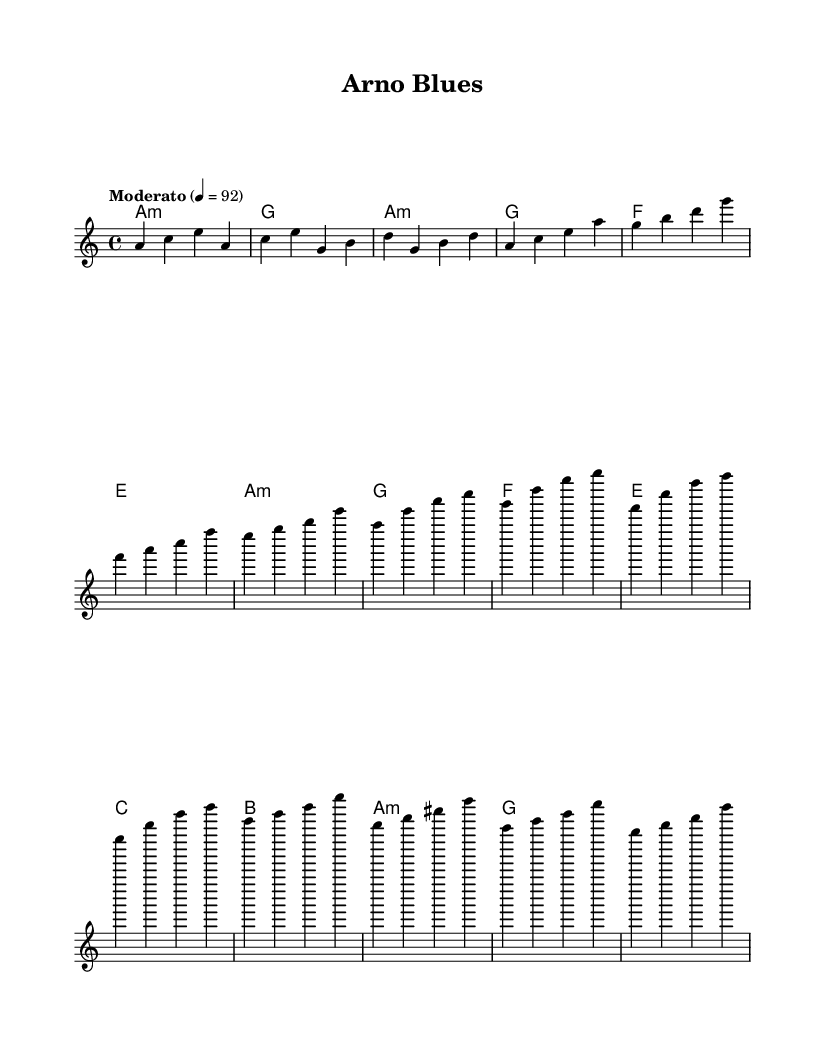What is the key signature of this music? The key signature shown in the piece is A minor, which typically has no sharps or flats. A minor is the relative minor of C major, and this is indicated at the beginning of the score.
Answer: A minor What is the time signature of this music? The time signature is 4/4, which indicates that there are four beats in a measure and a quarter note gets one beat. This can be observed from the time signature marking at the beginning of the score.
Answer: 4/4 What is the tempo marking of this music? The tempo marking is "Moderato," indicating a moderate speed of play. The number following that, 4 = 92, specifies the beats per minute, giving performers guidance on how fast to play the piece.
Answer: Moderato Which chord appears most frequently in the piece? The chord A minor appears frequently throughout the composition, particularly in the verses and chorus sections. This can be seen from the chord symbols provided, where A minor is consistently used.
Answer: A minor What forms does the structure of this piece suggest? The structure of the piece suggests a typical blues structure, comprising an intro, verses, a chorus, and a bridge. This is indicated by the clearly defined sections in the melody and corresponding harmonies outlined in the sheet music.
Answer: Blues structure What is the final chord in the bridge section? The final chord in the bridge section is G major, as indicated in the last measure of the bridge where the chord symbol appears. This shows the transition before returning to the melody.
Answer: G major What musical style is represented here? The musical style represented in this piece is Blues, characterized by its distinct chord progressions and expressive melodies. The harmonic choices and structure adhere to traditional blues forms and themes.
Answer: Blues 